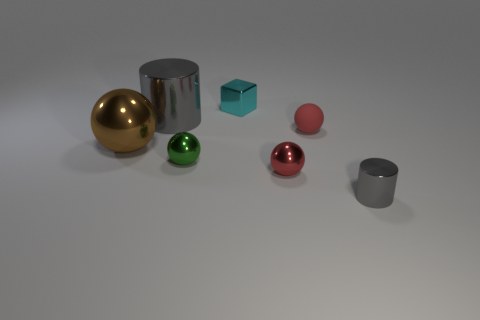What could the placement of these objects signify? The placement of the objects might suggest a study in geometry and material contrast, each item's position meticulously chosen to provide a sense of harmony and order within the frame. 